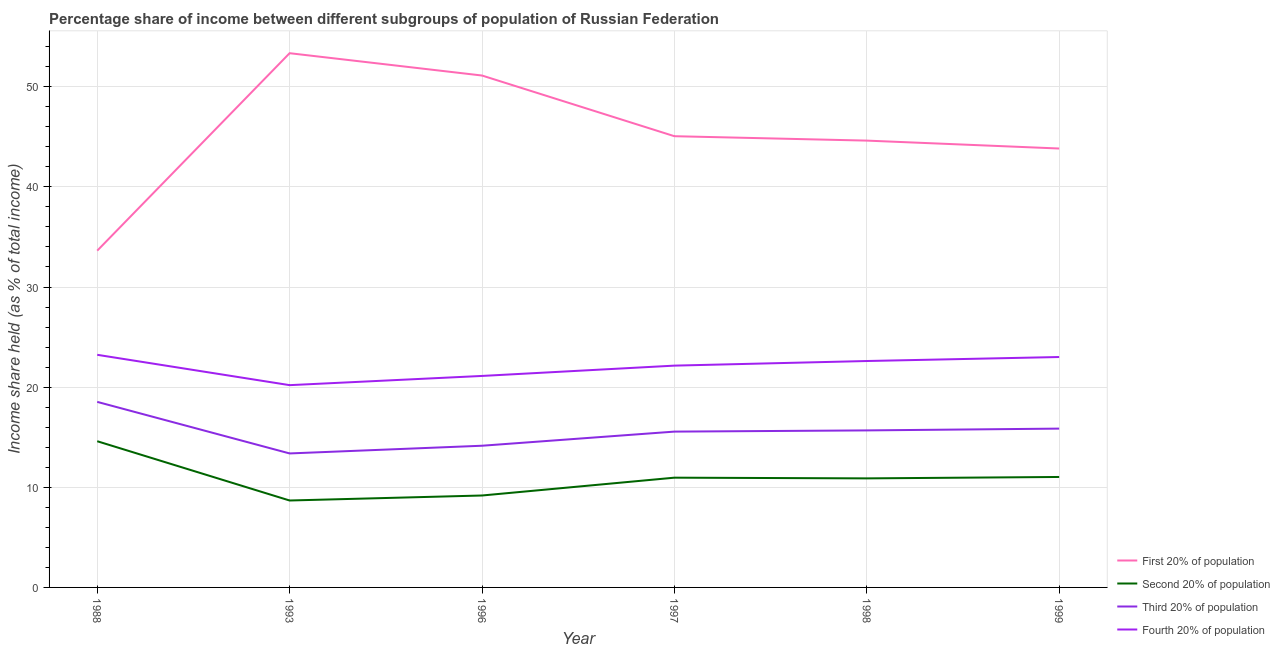Is the number of lines equal to the number of legend labels?
Keep it short and to the point. Yes. What is the share of the income held by first 20% of the population in 1997?
Your answer should be very brief. 45.06. Across all years, what is the maximum share of the income held by third 20% of the population?
Provide a short and direct response. 18.53. Across all years, what is the minimum share of the income held by second 20% of the population?
Provide a short and direct response. 8.68. In which year was the share of the income held by fourth 20% of the population maximum?
Make the answer very short. 1988. In which year was the share of the income held by first 20% of the population minimum?
Provide a short and direct response. 1988. What is the total share of the income held by fourth 20% of the population in the graph?
Give a very brief answer. 132.32. What is the difference between the share of the income held by fourth 20% of the population in 1988 and that in 1993?
Ensure brevity in your answer.  3.03. What is the difference between the share of the income held by second 20% of the population in 1998 and the share of the income held by fourth 20% of the population in 1996?
Offer a very short reply. -10.23. What is the average share of the income held by second 20% of the population per year?
Ensure brevity in your answer.  10.89. In the year 1999, what is the difference between the share of the income held by first 20% of the population and share of the income held by fourth 20% of the population?
Provide a succinct answer. 20.82. In how many years, is the share of the income held by first 20% of the population greater than 50 %?
Offer a terse response. 2. What is the ratio of the share of the income held by first 20% of the population in 1988 to that in 1999?
Your response must be concise. 0.77. Is the difference between the share of the income held by fourth 20% of the population in 1988 and 1993 greater than the difference between the share of the income held by third 20% of the population in 1988 and 1993?
Offer a terse response. No. What is the difference between the highest and the second highest share of the income held by third 20% of the population?
Offer a terse response. 2.67. What is the difference between the highest and the lowest share of the income held by fourth 20% of the population?
Provide a short and direct response. 3.03. Is it the case that in every year, the sum of the share of the income held by second 20% of the population and share of the income held by first 20% of the population is greater than the sum of share of the income held by fourth 20% of the population and share of the income held by third 20% of the population?
Provide a succinct answer. Yes. Is it the case that in every year, the sum of the share of the income held by first 20% of the population and share of the income held by second 20% of the population is greater than the share of the income held by third 20% of the population?
Offer a very short reply. Yes. Does the share of the income held by first 20% of the population monotonically increase over the years?
Offer a terse response. No. Is the share of the income held by third 20% of the population strictly greater than the share of the income held by second 20% of the population over the years?
Provide a succinct answer. Yes. Does the graph contain any zero values?
Your answer should be compact. No. Does the graph contain grids?
Provide a succinct answer. Yes. Where does the legend appear in the graph?
Ensure brevity in your answer.  Bottom right. How many legend labels are there?
Provide a short and direct response. 4. What is the title of the graph?
Offer a terse response. Percentage share of income between different subgroups of population of Russian Federation. What is the label or title of the X-axis?
Your answer should be very brief. Year. What is the label or title of the Y-axis?
Keep it short and to the point. Income share held (as % of total income). What is the Income share held (as % of total income) of First 20% of population in 1988?
Your answer should be very brief. 33.63. What is the Income share held (as % of total income) in Third 20% of population in 1988?
Keep it short and to the point. 18.53. What is the Income share held (as % of total income) of Fourth 20% of population in 1988?
Give a very brief answer. 23.23. What is the Income share held (as % of total income) of First 20% of population in 1993?
Give a very brief answer. 53.35. What is the Income share held (as % of total income) of Second 20% of population in 1993?
Provide a short and direct response. 8.68. What is the Income share held (as % of total income) of Third 20% of population in 1993?
Make the answer very short. 13.38. What is the Income share held (as % of total income) of Fourth 20% of population in 1993?
Give a very brief answer. 20.2. What is the Income share held (as % of total income) of First 20% of population in 1996?
Your answer should be very brief. 51.12. What is the Income share held (as % of total income) of Second 20% of population in 1996?
Give a very brief answer. 9.18. What is the Income share held (as % of total income) of Third 20% of population in 1996?
Give a very brief answer. 14.15. What is the Income share held (as % of total income) of Fourth 20% of population in 1996?
Your response must be concise. 21.12. What is the Income share held (as % of total income) of First 20% of population in 1997?
Ensure brevity in your answer.  45.06. What is the Income share held (as % of total income) in Second 20% of population in 1997?
Make the answer very short. 10.96. What is the Income share held (as % of total income) of Third 20% of population in 1997?
Make the answer very short. 15.56. What is the Income share held (as % of total income) in Fourth 20% of population in 1997?
Make the answer very short. 22.15. What is the Income share held (as % of total income) of First 20% of population in 1998?
Offer a terse response. 44.62. What is the Income share held (as % of total income) in Second 20% of population in 1998?
Keep it short and to the point. 10.89. What is the Income share held (as % of total income) in Third 20% of population in 1998?
Your answer should be compact. 15.68. What is the Income share held (as % of total income) of Fourth 20% of population in 1998?
Make the answer very short. 22.61. What is the Income share held (as % of total income) of First 20% of population in 1999?
Provide a succinct answer. 43.83. What is the Income share held (as % of total income) in Second 20% of population in 1999?
Offer a very short reply. 11.03. What is the Income share held (as % of total income) in Third 20% of population in 1999?
Keep it short and to the point. 15.86. What is the Income share held (as % of total income) of Fourth 20% of population in 1999?
Your answer should be compact. 23.01. Across all years, what is the maximum Income share held (as % of total income) of First 20% of population?
Provide a short and direct response. 53.35. Across all years, what is the maximum Income share held (as % of total income) of Third 20% of population?
Your answer should be very brief. 18.53. Across all years, what is the maximum Income share held (as % of total income) of Fourth 20% of population?
Keep it short and to the point. 23.23. Across all years, what is the minimum Income share held (as % of total income) in First 20% of population?
Your answer should be compact. 33.63. Across all years, what is the minimum Income share held (as % of total income) in Second 20% of population?
Give a very brief answer. 8.68. Across all years, what is the minimum Income share held (as % of total income) in Third 20% of population?
Offer a very short reply. 13.38. Across all years, what is the minimum Income share held (as % of total income) of Fourth 20% of population?
Provide a succinct answer. 20.2. What is the total Income share held (as % of total income) of First 20% of population in the graph?
Provide a short and direct response. 271.61. What is the total Income share held (as % of total income) of Second 20% of population in the graph?
Your answer should be compact. 65.34. What is the total Income share held (as % of total income) in Third 20% of population in the graph?
Give a very brief answer. 93.16. What is the total Income share held (as % of total income) of Fourth 20% of population in the graph?
Provide a succinct answer. 132.32. What is the difference between the Income share held (as % of total income) in First 20% of population in 1988 and that in 1993?
Give a very brief answer. -19.72. What is the difference between the Income share held (as % of total income) of Second 20% of population in 1988 and that in 1993?
Your answer should be compact. 5.92. What is the difference between the Income share held (as % of total income) in Third 20% of population in 1988 and that in 1993?
Give a very brief answer. 5.15. What is the difference between the Income share held (as % of total income) in Fourth 20% of population in 1988 and that in 1993?
Your answer should be very brief. 3.03. What is the difference between the Income share held (as % of total income) of First 20% of population in 1988 and that in 1996?
Your response must be concise. -17.49. What is the difference between the Income share held (as % of total income) in Second 20% of population in 1988 and that in 1996?
Make the answer very short. 5.42. What is the difference between the Income share held (as % of total income) of Third 20% of population in 1988 and that in 1996?
Your response must be concise. 4.38. What is the difference between the Income share held (as % of total income) of Fourth 20% of population in 1988 and that in 1996?
Your answer should be very brief. 2.11. What is the difference between the Income share held (as % of total income) of First 20% of population in 1988 and that in 1997?
Provide a short and direct response. -11.43. What is the difference between the Income share held (as % of total income) of Second 20% of population in 1988 and that in 1997?
Your answer should be compact. 3.64. What is the difference between the Income share held (as % of total income) of Third 20% of population in 1988 and that in 1997?
Provide a succinct answer. 2.97. What is the difference between the Income share held (as % of total income) of Fourth 20% of population in 1988 and that in 1997?
Offer a terse response. 1.08. What is the difference between the Income share held (as % of total income) of First 20% of population in 1988 and that in 1998?
Your response must be concise. -10.99. What is the difference between the Income share held (as % of total income) of Second 20% of population in 1988 and that in 1998?
Keep it short and to the point. 3.71. What is the difference between the Income share held (as % of total income) of Third 20% of population in 1988 and that in 1998?
Your answer should be compact. 2.85. What is the difference between the Income share held (as % of total income) in Fourth 20% of population in 1988 and that in 1998?
Provide a succinct answer. 0.62. What is the difference between the Income share held (as % of total income) in Second 20% of population in 1988 and that in 1999?
Provide a short and direct response. 3.57. What is the difference between the Income share held (as % of total income) of Third 20% of population in 1988 and that in 1999?
Provide a short and direct response. 2.67. What is the difference between the Income share held (as % of total income) of Fourth 20% of population in 1988 and that in 1999?
Your answer should be very brief. 0.22. What is the difference between the Income share held (as % of total income) in First 20% of population in 1993 and that in 1996?
Provide a short and direct response. 2.23. What is the difference between the Income share held (as % of total income) of Third 20% of population in 1993 and that in 1996?
Give a very brief answer. -0.77. What is the difference between the Income share held (as % of total income) in Fourth 20% of population in 1993 and that in 1996?
Ensure brevity in your answer.  -0.92. What is the difference between the Income share held (as % of total income) in First 20% of population in 1993 and that in 1997?
Offer a terse response. 8.29. What is the difference between the Income share held (as % of total income) in Second 20% of population in 1993 and that in 1997?
Give a very brief answer. -2.28. What is the difference between the Income share held (as % of total income) of Third 20% of population in 1993 and that in 1997?
Your response must be concise. -2.18. What is the difference between the Income share held (as % of total income) of Fourth 20% of population in 1993 and that in 1997?
Keep it short and to the point. -1.95. What is the difference between the Income share held (as % of total income) of First 20% of population in 1993 and that in 1998?
Give a very brief answer. 8.73. What is the difference between the Income share held (as % of total income) of Second 20% of population in 1993 and that in 1998?
Provide a succinct answer. -2.21. What is the difference between the Income share held (as % of total income) in Fourth 20% of population in 1993 and that in 1998?
Make the answer very short. -2.41. What is the difference between the Income share held (as % of total income) in First 20% of population in 1993 and that in 1999?
Provide a succinct answer. 9.52. What is the difference between the Income share held (as % of total income) in Second 20% of population in 1993 and that in 1999?
Provide a short and direct response. -2.35. What is the difference between the Income share held (as % of total income) of Third 20% of population in 1993 and that in 1999?
Keep it short and to the point. -2.48. What is the difference between the Income share held (as % of total income) of Fourth 20% of population in 1993 and that in 1999?
Offer a terse response. -2.81. What is the difference between the Income share held (as % of total income) of First 20% of population in 1996 and that in 1997?
Make the answer very short. 6.06. What is the difference between the Income share held (as % of total income) in Second 20% of population in 1996 and that in 1997?
Provide a succinct answer. -1.78. What is the difference between the Income share held (as % of total income) in Third 20% of population in 1996 and that in 1997?
Provide a short and direct response. -1.41. What is the difference between the Income share held (as % of total income) in Fourth 20% of population in 1996 and that in 1997?
Make the answer very short. -1.03. What is the difference between the Income share held (as % of total income) of Second 20% of population in 1996 and that in 1998?
Offer a terse response. -1.71. What is the difference between the Income share held (as % of total income) of Third 20% of population in 1996 and that in 1998?
Your response must be concise. -1.53. What is the difference between the Income share held (as % of total income) of Fourth 20% of population in 1996 and that in 1998?
Your answer should be very brief. -1.49. What is the difference between the Income share held (as % of total income) in First 20% of population in 1996 and that in 1999?
Ensure brevity in your answer.  7.29. What is the difference between the Income share held (as % of total income) in Second 20% of population in 1996 and that in 1999?
Provide a succinct answer. -1.85. What is the difference between the Income share held (as % of total income) in Third 20% of population in 1996 and that in 1999?
Your response must be concise. -1.71. What is the difference between the Income share held (as % of total income) in Fourth 20% of population in 1996 and that in 1999?
Your answer should be compact. -1.89. What is the difference between the Income share held (as % of total income) in First 20% of population in 1997 and that in 1998?
Your response must be concise. 0.44. What is the difference between the Income share held (as % of total income) of Second 20% of population in 1997 and that in 1998?
Keep it short and to the point. 0.07. What is the difference between the Income share held (as % of total income) in Third 20% of population in 1997 and that in 1998?
Keep it short and to the point. -0.12. What is the difference between the Income share held (as % of total income) in Fourth 20% of population in 1997 and that in 1998?
Offer a terse response. -0.46. What is the difference between the Income share held (as % of total income) of First 20% of population in 1997 and that in 1999?
Your answer should be compact. 1.23. What is the difference between the Income share held (as % of total income) in Second 20% of population in 1997 and that in 1999?
Give a very brief answer. -0.07. What is the difference between the Income share held (as % of total income) of Third 20% of population in 1997 and that in 1999?
Offer a terse response. -0.3. What is the difference between the Income share held (as % of total income) of Fourth 20% of population in 1997 and that in 1999?
Your response must be concise. -0.86. What is the difference between the Income share held (as % of total income) of First 20% of population in 1998 and that in 1999?
Offer a very short reply. 0.79. What is the difference between the Income share held (as % of total income) of Second 20% of population in 1998 and that in 1999?
Provide a short and direct response. -0.14. What is the difference between the Income share held (as % of total income) in Third 20% of population in 1998 and that in 1999?
Offer a very short reply. -0.18. What is the difference between the Income share held (as % of total income) in First 20% of population in 1988 and the Income share held (as % of total income) in Second 20% of population in 1993?
Your answer should be very brief. 24.95. What is the difference between the Income share held (as % of total income) in First 20% of population in 1988 and the Income share held (as % of total income) in Third 20% of population in 1993?
Give a very brief answer. 20.25. What is the difference between the Income share held (as % of total income) of First 20% of population in 1988 and the Income share held (as % of total income) of Fourth 20% of population in 1993?
Provide a short and direct response. 13.43. What is the difference between the Income share held (as % of total income) in Second 20% of population in 1988 and the Income share held (as % of total income) in Third 20% of population in 1993?
Keep it short and to the point. 1.22. What is the difference between the Income share held (as % of total income) in Second 20% of population in 1988 and the Income share held (as % of total income) in Fourth 20% of population in 1993?
Give a very brief answer. -5.6. What is the difference between the Income share held (as % of total income) of Third 20% of population in 1988 and the Income share held (as % of total income) of Fourth 20% of population in 1993?
Your answer should be compact. -1.67. What is the difference between the Income share held (as % of total income) in First 20% of population in 1988 and the Income share held (as % of total income) in Second 20% of population in 1996?
Ensure brevity in your answer.  24.45. What is the difference between the Income share held (as % of total income) in First 20% of population in 1988 and the Income share held (as % of total income) in Third 20% of population in 1996?
Give a very brief answer. 19.48. What is the difference between the Income share held (as % of total income) in First 20% of population in 1988 and the Income share held (as % of total income) in Fourth 20% of population in 1996?
Give a very brief answer. 12.51. What is the difference between the Income share held (as % of total income) of Second 20% of population in 1988 and the Income share held (as % of total income) of Third 20% of population in 1996?
Provide a short and direct response. 0.45. What is the difference between the Income share held (as % of total income) of Second 20% of population in 1988 and the Income share held (as % of total income) of Fourth 20% of population in 1996?
Ensure brevity in your answer.  -6.52. What is the difference between the Income share held (as % of total income) of Third 20% of population in 1988 and the Income share held (as % of total income) of Fourth 20% of population in 1996?
Your answer should be compact. -2.59. What is the difference between the Income share held (as % of total income) in First 20% of population in 1988 and the Income share held (as % of total income) in Second 20% of population in 1997?
Your answer should be compact. 22.67. What is the difference between the Income share held (as % of total income) of First 20% of population in 1988 and the Income share held (as % of total income) of Third 20% of population in 1997?
Offer a very short reply. 18.07. What is the difference between the Income share held (as % of total income) in First 20% of population in 1988 and the Income share held (as % of total income) in Fourth 20% of population in 1997?
Offer a very short reply. 11.48. What is the difference between the Income share held (as % of total income) in Second 20% of population in 1988 and the Income share held (as % of total income) in Third 20% of population in 1997?
Offer a terse response. -0.96. What is the difference between the Income share held (as % of total income) of Second 20% of population in 1988 and the Income share held (as % of total income) of Fourth 20% of population in 1997?
Your response must be concise. -7.55. What is the difference between the Income share held (as % of total income) in Third 20% of population in 1988 and the Income share held (as % of total income) in Fourth 20% of population in 1997?
Offer a terse response. -3.62. What is the difference between the Income share held (as % of total income) of First 20% of population in 1988 and the Income share held (as % of total income) of Second 20% of population in 1998?
Give a very brief answer. 22.74. What is the difference between the Income share held (as % of total income) in First 20% of population in 1988 and the Income share held (as % of total income) in Third 20% of population in 1998?
Provide a succinct answer. 17.95. What is the difference between the Income share held (as % of total income) in First 20% of population in 1988 and the Income share held (as % of total income) in Fourth 20% of population in 1998?
Offer a very short reply. 11.02. What is the difference between the Income share held (as % of total income) of Second 20% of population in 1988 and the Income share held (as % of total income) of Third 20% of population in 1998?
Your answer should be very brief. -1.08. What is the difference between the Income share held (as % of total income) of Second 20% of population in 1988 and the Income share held (as % of total income) of Fourth 20% of population in 1998?
Your answer should be very brief. -8.01. What is the difference between the Income share held (as % of total income) of Third 20% of population in 1988 and the Income share held (as % of total income) of Fourth 20% of population in 1998?
Your answer should be very brief. -4.08. What is the difference between the Income share held (as % of total income) in First 20% of population in 1988 and the Income share held (as % of total income) in Second 20% of population in 1999?
Your answer should be very brief. 22.6. What is the difference between the Income share held (as % of total income) of First 20% of population in 1988 and the Income share held (as % of total income) of Third 20% of population in 1999?
Make the answer very short. 17.77. What is the difference between the Income share held (as % of total income) in First 20% of population in 1988 and the Income share held (as % of total income) in Fourth 20% of population in 1999?
Keep it short and to the point. 10.62. What is the difference between the Income share held (as % of total income) of Second 20% of population in 1988 and the Income share held (as % of total income) of Third 20% of population in 1999?
Your response must be concise. -1.26. What is the difference between the Income share held (as % of total income) of Second 20% of population in 1988 and the Income share held (as % of total income) of Fourth 20% of population in 1999?
Keep it short and to the point. -8.41. What is the difference between the Income share held (as % of total income) in Third 20% of population in 1988 and the Income share held (as % of total income) in Fourth 20% of population in 1999?
Make the answer very short. -4.48. What is the difference between the Income share held (as % of total income) in First 20% of population in 1993 and the Income share held (as % of total income) in Second 20% of population in 1996?
Make the answer very short. 44.17. What is the difference between the Income share held (as % of total income) in First 20% of population in 1993 and the Income share held (as % of total income) in Third 20% of population in 1996?
Your response must be concise. 39.2. What is the difference between the Income share held (as % of total income) in First 20% of population in 1993 and the Income share held (as % of total income) in Fourth 20% of population in 1996?
Offer a terse response. 32.23. What is the difference between the Income share held (as % of total income) of Second 20% of population in 1993 and the Income share held (as % of total income) of Third 20% of population in 1996?
Your answer should be very brief. -5.47. What is the difference between the Income share held (as % of total income) of Second 20% of population in 1993 and the Income share held (as % of total income) of Fourth 20% of population in 1996?
Your response must be concise. -12.44. What is the difference between the Income share held (as % of total income) in Third 20% of population in 1993 and the Income share held (as % of total income) in Fourth 20% of population in 1996?
Keep it short and to the point. -7.74. What is the difference between the Income share held (as % of total income) in First 20% of population in 1993 and the Income share held (as % of total income) in Second 20% of population in 1997?
Your answer should be compact. 42.39. What is the difference between the Income share held (as % of total income) in First 20% of population in 1993 and the Income share held (as % of total income) in Third 20% of population in 1997?
Offer a terse response. 37.79. What is the difference between the Income share held (as % of total income) in First 20% of population in 1993 and the Income share held (as % of total income) in Fourth 20% of population in 1997?
Offer a terse response. 31.2. What is the difference between the Income share held (as % of total income) in Second 20% of population in 1993 and the Income share held (as % of total income) in Third 20% of population in 1997?
Your answer should be very brief. -6.88. What is the difference between the Income share held (as % of total income) in Second 20% of population in 1993 and the Income share held (as % of total income) in Fourth 20% of population in 1997?
Give a very brief answer. -13.47. What is the difference between the Income share held (as % of total income) of Third 20% of population in 1993 and the Income share held (as % of total income) of Fourth 20% of population in 1997?
Offer a very short reply. -8.77. What is the difference between the Income share held (as % of total income) of First 20% of population in 1993 and the Income share held (as % of total income) of Second 20% of population in 1998?
Ensure brevity in your answer.  42.46. What is the difference between the Income share held (as % of total income) of First 20% of population in 1993 and the Income share held (as % of total income) of Third 20% of population in 1998?
Ensure brevity in your answer.  37.67. What is the difference between the Income share held (as % of total income) in First 20% of population in 1993 and the Income share held (as % of total income) in Fourth 20% of population in 1998?
Your response must be concise. 30.74. What is the difference between the Income share held (as % of total income) in Second 20% of population in 1993 and the Income share held (as % of total income) in Third 20% of population in 1998?
Provide a succinct answer. -7. What is the difference between the Income share held (as % of total income) in Second 20% of population in 1993 and the Income share held (as % of total income) in Fourth 20% of population in 1998?
Offer a terse response. -13.93. What is the difference between the Income share held (as % of total income) in Third 20% of population in 1993 and the Income share held (as % of total income) in Fourth 20% of population in 1998?
Provide a succinct answer. -9.23. What is the difference between the Income share held (as % of total income) in First 20% of population in 1993 and the Income share held (as % of total income) in Second 20% of population in 1999?
Your answer should be compact. 42.32. What is the difference between the Income share held (as % of total income) of First 20% of population in 1993 and the Income share held (as % of total income) of Third 20% of population in 1999?
Your response must be concise. 37.49. What is the difference between the Income share held (as % of total income) in First 20% of population in 1993 and the Income share held (as % of total income) in Fourth 20% of population in 1999?
Provide a short and direct response. 30.34. What is the difference between the Income share held (as % of total income) of Second 20% of population in 1993 and the Income share held (as % of total income) of Third 20% of population in 1999?
Your response must be concise. -7.18. What is the difference between the Income share held (as % of total income) in Second 20% of population in 1993 and the Income share held (as % of total income) in Fourth 20% of population in 1999?
Make the answer very short. -14.33. What is the difference between the Income share held (as % of total income) in Third 20% of population in 1993 and the Income share held (as % of total income) in Fourth 20% of population in 1999?
Your answer should be compact. -9.63. What is the difference between the Income share held (as % of total income) of First 20% of population in 1996 and the Income share held (as % of total income) of Second 20% of population in 1997?
Give a very brief answer. 40.16. What is the difference between the Income share held (as % of total income) of First 20% of population in 1996 and the Income share held (as % of total income) of Third 20% of population in 1997?
Provide a short and direct response. 35.56. What is the difference between the Income share held (as % of total income) in First 20% of population in 1996 and the Income share held (as % of total income) in Fourth 20% of population in 1997?
Ensure brevity in your answer.  28.97. What is the difference between the Income share held (as % of total income) in Second 20% of population in 1996 and the Income share held (as % of total income) in Third 20% of population in 1997?
Your answer should be very brief. -6.38. What is the difference between the Income share held (as % of total income) in Second 20% of population in 1996 and the Income share held (as % of total income) in Fourth 20% of population in 1997?
Provide a short and direct response. -12.97. What is the difference between the Income share held (as % of total income) of Third 20% of population in 1996 and the Income share held (as % of total income) of Fourth 20% of population in 1997?
Your answer should be compact. -8. What is the difference between the Income share held (as % of total income) in First 20% of population in 1996 and the Income share held (as % of total income) in Second 20% of population in 1998?
Your answer should be very brief. 40.23. What is the difference between the Income share held (as % of total income) in First 20% of population in 1996 and the Income share held (as % of total income) in Third 20% of population in 1998?
Offer a terse response. 35.44. What is the difference between the Income share held (as % of total income) in First 20% of population in 1996 and the Income share held (as % of total income) in Fourth 20% of population in 1998?
Your answer should be compact. 28.51. What is the difference between the Income share held (as % of total income) of Second 20% of population in 1996 and the Income share held (as % of total income) of Third 20% of population in 1998?
Offer a terse response. -6.5. What is the difference between the Income share held (as % of total income) in Second 20% of population in 1996 and the Income share held (as % of total income) in Fourth 20% of population in 1998?
Offer a terse response. -13.43. What is the difference between the Income share held (as % of total income) in Third 20% of population in 1996 and the Income share held (as % of total income) in Fourth 20% of population in 1998?
Give a very brief answer. -8.46. What is the difference between the Income share held (as % of total income) of First 20% of population in 1996 and the Income share held (as % of total income) of Second 20% of population in 1999?
Your answer should be compact. 40.09. What is the difference between the Income share held (as % of total income) of First 20% of population in 1996 and the Income share held (as % of total income) of Third 20% of population in 1999?
Keep it short and to the point. 35.26. What is the difference between the Income share held (as % of total income) of First 20% of population in 1996 and the Income share held (as % of total income) of Fourth 20% of population in 1999?
Offer a very short reply. 28.11. What is the difference between the Income share held (as % of total income) of Second 20% of population in 1996 and the Income share held (as % of total income) of Third 20% of population in 1999?
Your response must be concise. -6.68. What is the difference between the Income share held (as % of total income) in Second 20% of population in 1996 and the Income share held (as % of total income) in Fourth 20% of population in 1999?
Make the answer very short. -13.83. What is the difference between the Income share held (as % of total income) in Third 20% of population in 1996 and the Income share held (as % of total income) in Fourth 20% of population in 1999?
Give a very brief answer. -8.86. What is the difference between the Income share held (as % of total income) in First 20% of population in 1997 and the Income share held (as % of total income) in Second 20% of population in 1998?
Provide a short and direct response. 34.17. What is the difference between the Income share held (as % of total income) in First 20% of population in 1997 and the Income share held (as % of total income) in Third 20% of population in 1998?
Offer a very short reply. 29.38. What is the difference between the Income share held (as % of total income) of First 20% of population in 1997 and the Income share held (as % of total income) of Fourth 20% of population in 1998?
Ensure brevity in your answer.  22.45. What is the difference between the Income share held (as % of total income) in Second 20% of population in 1997 and the Income share held (as % of total income) in Third 20% of population in 1998?
Ensure brevity in your answer.  -4.72. What is the difference between the Income share held (as % of total income) in Second 20% of population in 1997 and the Income share held (as % of total income) in Fourth 20% of population in 1998?
Your response must be concise. -11.65. What is the difference between the Income share held (as % of total income) of Third 20% of population in 1997 and the Income share held (as % of total income) of Fourth 20% of population in 1998?
Provide a short and direct response. -7.05. What is the difference between the Income share held (as % of total income) of First 20% of population in 1997 and the Income share held (as % of total income) of Second 20% of population in 1999?
Your answer should be very brief. 34.03. What is the difference between the Income share held (as % of total income) of First 20% of population in 1997 and the Income share held (as % of total income) of Third 20% of population in 1999?
Your answer should be compact. 29.2. What is the difference between the Income share held (as % of total income) in First 20% of population in 1997 and the Income share held (as % of total income) in Fourth 20% of population in 1999?
Keep it short and to the point. 22.05. What is the difference between the Income share held (as % of total income) in Second 20% of population in 1997 and the Income share held (as % of total income) in Fourth 20% of population in 1999?
Offer a very short reply. -12.05. What is the difference between the Income share held (as % of total income) of Third 20% of population in 1997 and the Income share held (as % of total income) of Fourth 20% of population in 1999?
Offer a very short reply. -7.45. What is the difference between the Income share held (as % of total income) of First 20% of population in 1998 and the Income share held (as % of total income) of Second 20% of population in 1999?
Offer a very short reply. 33.59. What is the difference between the Income share held (as % of total income) in First 20% of population in 1998 and the Income share held (as % of total income) in Third 20% of population in 1999?
Give a very brief answer. 28.76. What is the difference between the Income share held (as % of total income) in First 20% of population in 1998 and the Income share held (as % of total income) in Fourth 20% of population in 1999?
Provide a succinct answer. 21.61. What is the difference between the Income share held (as % of total income) in Second 20% of population in 1998 and the Income share held (as % of total income) in Third 20% of population in 1999?
Your response must be concise. -4.97. What is the difference between the Income share held (as % of total income) in Second 20% of population in 1998 and the Income share held (as % of total income) in Fourth 20% of population in 1999?
Offer a very short reply. -12.12. What is the difference between the Income share held (as % of total income) in Third 20% of population in 1998 and the Income share held (as % of total income) in Fourth 20% of population in 1999?
Your response must be concise. -7.33. What is the average Income share held (as % of total income) in First 20% of population per year?
Provide a short and direct response. 45.27. What is the average Income share held (as % of total income) in Second 20% of population per year?
Your answer should be very brief. 10.89. What is the average Income share held (as % of total income) of Third 20% of population per year?
Make the answer very short. 15.53. What is the average Income share held (as % of total income) in Fourth 20% of population per year?
Provide a succinct answer. 22.05. In the year 1988, what is the difference between the Income share held (as % of total income) of First 20% of population and Income share held (as % of total income) of Second 20% of population?
Offer a very short reply. 19.03. In the year 1988, what is the difference between the Income share held (as % of total income) in First 20% of population and Income share held (as % of total income) in Third 20% of population?
Your response must be concise. 15.1. In the year 1988, what is the difference between the Income share held (as % of total income) of First 20% of population and Income share held (as % of total income) of Fourth 20% of population?
Provide a short and direct response. 10.4. In the year 1988, what is the difference between the Income share held (as % of total income) in Second 20% of population and Income share held (as % of total income) in Third 20% of population?
Your response must be concise. -3.93. In the year 1988, what is the difference between the Income share held (as % of total income) in Second 20% of population and Income share held (as % of total income) in Fourth 20% of population?
Provide a short and direct response. -8.63. In the year 1988, what is the difference between the Income share held (as % of total income) of Third 20% of population and Income share held (as % of total income) of Fourth 20% of population?
Your response must be concise. -4.7. In the year 1993, what is the difference between the Income share held (as % of total income) of First 20% of population and Income share held (as % of total income) of Second 20% of population?
Keep it short and to the point. 44.67. In the year 1993, what is the difference between the Income share held (as % of total income) of First 20% of population and Income share held (as % of total income) of Third 20% of population?
Keep it short and to the point. 39.97. In the year 1993, what is the difference between the Income share held (as % of total income) of First 20% of population and Income share held (as % of total income) of Fourth 20% of population?
Provide a succinct answer. 33.15. In the year 1993, what is the difference between the Income share held (as % of total income) in Second 20% of population and Income share held (as % of total income) in Third 20% of population?
Your answer should be very brief. -4.7. In the year 1993, what is the difference between the Income share held (as % of total income) in Second 20% of population and Income share held (as % of total income) in Fourth 20% of population?
Give a very brief answer. -11.52. In the year 1993, what is the difference between the Income share held (as % of total income) in Third 20% of population and Income share held (as % of total income) in Fourth 20% of population?
Your answer should be very brief. -6.82. In the year 1996, what is the difference between the Income share held (as % of total income) of First 20% of population and Income share held (as % of total income) of Second 20% of population?
Keep it short and to the point. 41.94. In the year 1996, what is the difference between the Income share held (as % of total income) in First 20% of population and Income share held (as % of total income) in Third 20% of population?
Your answer should be compact. 36.97. In the year 1996, what is the difference between the Income share held (as % of total income) in First 20% of population and Income share held (as % of total income) in Fourth 20% of population?
Make the answer very short. 30. In the year 1996, what is the difference between the Income share held (as % of total income) in Second 20% of population and Income share held (as % of total income) in Third 20% of population?
Offer a terse response. -4.97. In the year 1996, what is the difference between the Income share held (as % of total income) in Second 20% of population and Income share held (as % of total income) in Fourth 20% of population?
Your response must be concise. -11.94. In the year 1996, what is the difference between the Income share held (as % of total income) in Third 20% of population and Income share held (as % of total income) in Fourth 20% of population?
Your answer should be compact. -6.97. In the year 1997, what is the difference between the Income share held (as % of total income) of First 20% of population and Income share held (as % of total income) of Second 20% of population?
Your answer should be compact. 34.1. In the year 1997, what is the difference between the Income share held (as % of total income) in First 20% of population and Income share held (as % of total income) in Third 20% of population?
Offer a terse response. 29.5. In the year 1997, what is the difference between the Income share held (as % of total income) in First 20% of population and Income share held (as % of total income) in Fourth 20% of population?
Give a very brief answer. 22.91. In the year 1997, what is the difference between the Income share held (as % of total income) of Second 20% of population and Income share held (as % of total income) of Fourth 20% of population?
Offer a very short reply. -11.19. In the year 1997, what is the difference between the Income share held (as % of total income) of Third 20% of population and Income share held (as % of total income) of Fourth 20% of population?
Give a very brief answer. -6.59. In the year 1998, what is the difference between the Income share held (as % of total income) of First 20% of population and Income share held (as % of total income) of Second 20% of population?
Provide a short and direct response. 33.73. In the year 1998, what is the difference between the Income share held (as % of total income) of First 20% of population and Income share held (as % of total income) of Third 20% of population?
Ensure brevity in your answer.  28.94. In the year 1998, what is the difference between the Income share held (as % of total income) of First 20% of population and Income share held (as % of total income) of Fourth 20% of population?
Offer a very short reply. 22.01. In the year 1998, what is the difference between the Income share held (as % of total income) of Second 20% of population and Income share held (as % of total income) of Third 20% of population?
Your response must be concise. -4.79. In the year 1998, what is the difference between the Income share held (as % of total income) of Second 20% of population and Income share held (as % of total income) of Fourth 20% of population?
Your answer should be compact. -11.72. In the year 1998, what is the difference between the Income share held (as % of total income) of Third 20% of population and Income share held (as % of total income) of Fourth 20% of population?
Ensure brevity in your answer.  -6.93. In the year 1999, what is the difference between the Income share held (as % of total income) in First 20% of population and Income share held (as % of total income) in Second 20% of population?
Your answer should be compact. 32.8. In the year 1999, what is the difference between the Income share held (as % of total income) of First 20% of population and Income share held (as % of total income) of Third 20% of population?
Your response must be concise. 27.97. In the year 1999, what is the difference between the Income share held (as % of total income) of First 20% of population and Income share held (as % of total income) of Fourth 20% of population?
Ensure brevity in your answer.  20.82. In the year 1999, what is the difference between the Income share held (as % of total income) of Second 20% of population and Income share held (as % of total income) of Third 20% of population?
Provide a succinct answer. -4.83. In the year 1999, what is the difference between the Income share held (as % of total income) of Second 20% of population and Income share held (as % of total income) of Fourth 20% of population?
Your response must be concise. -11.98. In the year 1999, what is the difference between the Income share held (as % of total income) of Third 20% of population and Income share held (as % of total income) of Fourth 20% of population?
Offer a very short reply. -7.15. What is the ratio of the Income share held (as % of total income) in First 20% of population in 1988 to that in 1993?
Offer a very short reply. 0.63. What is the ratio of the Income share held (as % of total income) in Second 20% of population in 1988 to that in 1993?
Your answer should be compact. 1.68. What is the ratio of the Income share held (as % of total income) of Third 20% of population in 1988 to that in 1993?
Make the answer very short. 1.38. What is the ratio of the Income share held (as % of total income) of Fourth 20% of population in 1988 to that in 1993?
Offer a very short reply. 1.15. What is the ratio of the Income share held (as % of total income) of First 20% of population in 1988 to that in 1996?
Provide a short and direct response. 0.66. What is the ratio of the Income share held (as % of total income) of Second 20% of population in 1988 to that in 1996?
Your response must be concise. 1.59. What is the ratio of the Income share held (as % of total income) of Third 20% of population in 1988 to that in 1996?
Offer a very short reply. 1.31. What is the ratio of the Income share held (as % of total income) in Fourth 20% of population in 1988 to that in 1996?
Your answer should be compact. 1.1. What is the ratio of the Income share held (as % of total income) of First 20% of population in 1988 to that in 1997?
Give a very brief answer. 0.75. What is the ratio of the Income share held (as % of total income) in Second 20% of population in 1988 to that in 1997?
Give a very brief answer. 1.33. What is the ratio of the Income share held (as % of total income) in Third 20% of population in 1988 to that in 1997?
Provide a short and direct response. 1.19. What is the ratio of the Income share held (as % of total income) in Fourth 20% of population in 1988 to that in 1997?
Give a very brief answer. 1.05. What is the ratio of the Income share held (as % of total income) in First 20% of population in 1988 to that in 1998?
Ensure brevity in your answer.  0.75. What is the ratio of the Income share held (as % of total income) in Second 20% of population in 1988 to that in 1998?
Your answer should be compact. 1.34. What is the ratio of the Income share held (as % of total income) in Third 20% of population in 1988 to that in 1998?
Offer a terse response. 1.18. What is the ratio of the Income share held (as % of total income) in Fourth 20% of population in 1988 to that in 1998?
Offer a terse response. 1.03. What is the ratio of the Income share held (as % of total income) in First 20% of population in 1988 to that in 1999?
Offer a very short reply. 0.77. What is the ratio of the Income share held (as % of total income) of Second 20% of population in 1988 to that in 1999?
Give a very brief answer. 1.32. What is the ratio of the Income share held (as % of total income) of Third 20% of population in 1988 to that in 1999?
Make the answer very short. 1.17. What is the ratio of the Income share held (as % of total income) in Fourth 20% of population in 1988 to that in 1999?
Give a very brief answer. 1.01. What is the ratio of the Income share held (as % of total income) of First 20% of population in 1993 to that in 1996?
Keep it short and to the point. 1.04. What is the ratio of the Income share held (as % of total income) in Second 20% of population in 1993 to that in 1996?
Make the answer very short. 0.95. What is the ratio of the Income share held (as % of total income) in Third 20% of population in 1993 to that in 1996?
Keep it short and to the point. 0.95. What is the ratio of the Income share held (as % of total income) of Fourth 20% of population in 1993 to that in 1996?
Make the answer very short. 0.96. What is the ratio of the Income share held (as % of total income) in First 20% of population in 1993 to that in 1997?
Provide a succinct answer. 1.18. What is the ratio of the Income share held (as % of total income) of Second 20% of population in 1993 to that in 1997?
Provide a succinct answer. 0.79. What is the ratio of the Income share held (as % of total income) of Third 20% of population in 1993 to that in 1997?
Provide a succinct answer. 0.86. What is the ratio of the Income share held (as % of total income) in Fourth 20% of population in 1993 to that in 1997?
Your answer should be very brief. 0.91. What is the ratio of the Income share held (as % of total income) in First 20% of population in 1993 to that in 1998?
Your response must be concise. 1.2. What is the ratio of the Income share held (as % of total income) in Second 20% of population in 1993 to that in 1998?
Provide a short and direct response. 0.8. What is the ratio of the Income share held (as % of total income) in Third 20% of population in 1993 to that in 1998?
Offer a very short reply. 0.85. What is the ratio of the Income share held (as % of total income) in Fourth 20% of population in 1993 to that in 1998?
Make the answer very short. 0.89. What is the ratio of the Income share held (as % of total income) of First 20% of population in 1993 to that in 1999?
Keep it short and to the point. 1.22. What is the ratio of the Income share held (as % of total income) of Second 20% of population in 1993 to that in 1999?
Give a very brief answer. 0.79. What is the ratio of the Income share held (as % of total income) in Third 20% of population in 1993 to that in 1999?
Give a very brief answer. 0.84. What is the ratio of the Income share held (as % of total income) in Fourth 20% of population in 1993 to that in 1999?
Your answer should be very brief. 0.88. What is the ratio of the Income share held (as % of total income) of First 20% of population in 1996 to that in 1997?
Ensure brevity in your answer.  1.13. What is the ratio of the Income share held (as % of total income) in Second 20% of population in 1996 to that in 1997?
Your answer should be compact. 0.84. What is the ratio of the Income share held (as % of total income) in Third 20% of population in 1996 to that in 1997?
Offer a very short reply. 0.91. What is the ratio of the Income share held (as % of total income) of Fourth 20% of population in 1996 to that in 1997?
Provide a short and direct response. 0.95. What is the ratio of the Income share held (as % of total income) of First 20% of population in 1996 to that in 1998?
Give a very brief answer. 1.15. What is the ratio of the Income share held (as % of total income) in Second 20% of population in 1996 to that in 1998?
Make the answer very short. 0.84. What is the ratio of the Income share held (as % of total income) of Third 20% of population in 1996 to that in 1998?
Give a very brief answer. 0.9. What is the ratio of the Income share held (as % of total income) in Fourth 20% of population in 1996 to that in 1998?
Provide a succinct answer. 0.93. What is the ratio of the Income share held (as % of total income) of First 20% of population in 1996 to that in 1999?
Make the answer very short. 1.17. What is the ratio of the Income share held (as % of total income) in Second 20% of population in 1996 to that in 1999?
Offer a terse response. 0.83. What is the ratio of the Income share held (as % of total income) in Third 20% of population in 1996 to that in 1999?
Ensure brevity in your answer.  0.89. What is the ratio of the Income share held (as % of total income) in Fourth 20% of population in 1996 to that in 1999?
Ensure brevity in your answer.  0.92. What is the ratio of the Income share held (as % of total income) of First 20% of population in 1997 to that in 1998?
Keep it short and to the point. 1.01. What is the ratio of the Income share held (as % of total income) of Second 20% of population in 1997 to that in 1998?
Your answer should be compact. 1.01. What is the ratio of the Income share held (as % of total income) in Fourth 20% of population in 1997 to that in 1998?
Give a very brief answer. 0.98. What is the ratio of the Income share held (as % of total income) of First 20% of population in 1997 to that in 1999?
Make the answer very short. 1.03. What is the ratio of the Income share held (as % of total income) of Third 20% of population in 1997 to that in 1999?
Offer a very short reply. 0.98. What is the ratio of the Income share held (as % of total income) in Fourth 20% of population in 1997 to that in 1999?
Ensure brevity in your answer.  0.96. What is the ratio of the Income share held (as % of total income) of First 20% of population in 1998 to that in 1999?
Offer a terse response. 1.02. What is the ratio of the Income share held (as % of total income) of Second 20% of population in 1998 to that in 1999?
Make the answer very short. 0.99. What is the ratio of the Income share held (as % of total income) of Third 20% of population in 1998 to that in 1999?
Offer a very short reply. 0.99. What is the ratio of the Income share held (as % of total income) of Fourth 20% of population in 1998 to that in 1999?
Give a very brief answer. 0.98. What is the difference between the highest and the second highest Income share held (as % of total income) of First 20% of population?
Make the answer very short. 2.23. What is the difference between the highest and the second highest Income share held (as % of total income) of Second 20% of population?
Give a very brief answer. 3.57. What is the difference between the highest and the second highest Income share held (as % of total income) in Third 20% of population?
Provide a short and direct response. 2.67. What is the difference between the highest and the second highest Income share held (as % of total income) of Fourth 20% of population?
Provide a succinct answer. 0.22. What is the difference between the highest and the lowest Income share held (as % of total income) in First 20% of population?
Ensure brevity in your answer.  19.72. What is the difference between the highest and the lowest Income share held (as % of total income) of Second 20% of population?
Make the answer very short. 5.92. What is the difference between the highest and the lowest Income share held (as % of total income) in Third 20% of population?
Your answer should be very brief. 5.15. What is the difference between the highest and the lowest Income share held (as % of total income) in Fourth 20% of population?
Your response must be concise. 3.03. 